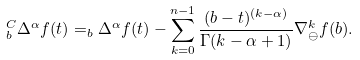Convert formula to latex. <formula><loc_0><loc_0><loc_500><loc_500>_ { b } ^ { C } \Delta ^ { \alpha } f ( t ) = _ { b } \Delta ^ { \alpha } f ( t ) - \sum _ { k = 0 } ^ { n - 1 } \frac { ( b - t ) ^ { ( k - \alpha ) } } { \Gamma ( k - \alpha + 1 ) } \nabla _ { \ominus } ^ { k } f ( b ) .</formula> 